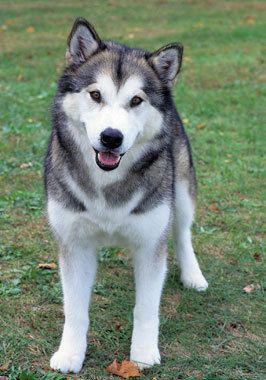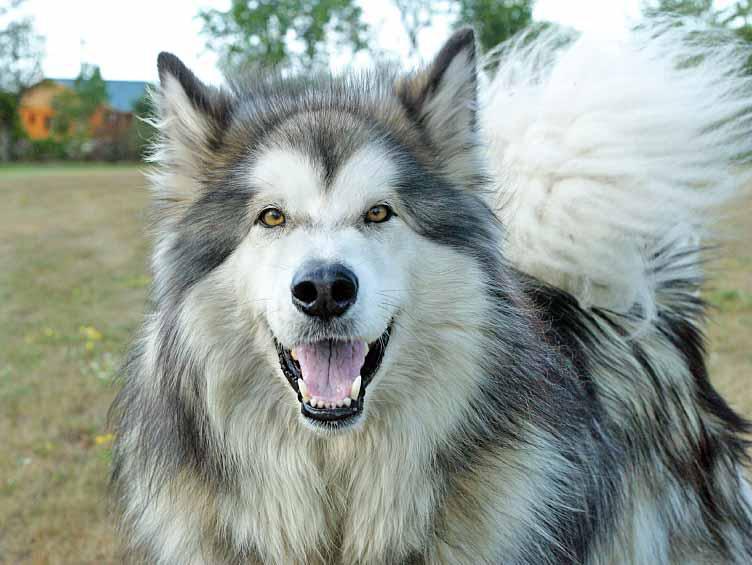The first image is the image on the left, the second image is the image on the right. Evaluate the accuracy of this statement regarding the images: "At least one of the dogs is opening its mouth.". Is it true? Answer yes or no. Yes. The first image is the image on the left, the second image is the image on the right. Given the left and right images, does the statement "At least one dog has blue eyes." hold true? Answer yes or no. No. 